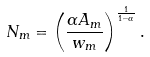<formula> <loc_0><loc_0><loc_500><loc_500>N _ { m } = \left ( \frac { \alpha A _ { m } } { w _ { m } } \right ) ^ { \frac { 1 } { 1 - \alpha } } .</formula> 